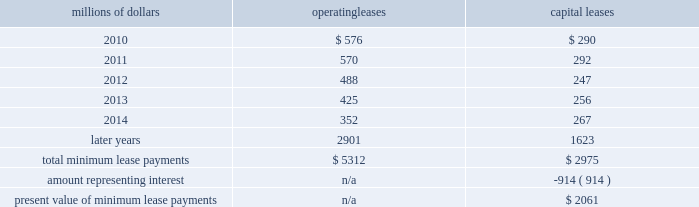14 .
Leases we lease certain locomotives , freight cars , and other property .
The consolidated statement of financial position as of december 31 , 2009 and 2008 included $ 2754 million , net of $ 927 million of accumulated depreciation , and $ 2024 million , net of $ 869 million of accumulated depreciation , respectively , for properties held under capital leases .
A charge to income resulting from the depreciation for assets held under capital leases is included within depreciation expense in our consolidated statements of income .
Future minimum lease payments for operating and capital leases with initial or remaining non-cancelable lease terms in excess of one year as of december 31 , 2009 were as follows : millions of dollars operating leases capital leases .
The majority of capital lease payments relate to locomotives .
Rent expense for operating leases with terms exceeding one month was $ 686 million in 2009 , $ 747 million in 2008 , and $ 810 million in 2007 .
When cash rental payments are not made on a straight-line basis , we recognize variable rental expense on a straight-line basis over the lease term .
Contingent rentals and sub-rentals are not significant .
15 .
Commitments and contingencies asserted and unasserted claims 2013 various claims and lawsuits are pending against us and certain of our subsidiaries .
We cannot fully determine the effect of all asserted and unasserted claims on our consolidated results of operations , financial condition , or liquidity ; however , to the extent possible , where asserted and unasserted claims are considered probable and where such claims can be reasonably estimated , we have recorded a liability .
We do not expect that any known lawsuits , claims , environmental costs , commitments , contingent liabilities , or guarantees will have a material adverse effect on our consolidated results of operations , financial condition , or liquidity after taking into account liabilities and insurance recoveries previously recorded for these matters .
Personal injury 2013 the cost of personal injuries to employees and others related to our activities is charged to expense based on estimates of the ultimate cost and number of incidents each year .
We use third-party actuaries to assist us in measuring the expense and liability , including unasserted claims .
The federal employers 2019 liability act ( fela ) governs compensation for work-related accidents .
Under fela , damages are assessed based on a finding of fault through litigation or out-of-court settlements .
We offer a comprehensive variety of services and rehabilitation programs for employees who are injured at .
What portion of 2009 capital leases are current liabilities? 
Computations: (290 / 1623)
Answer: 0.17868. 